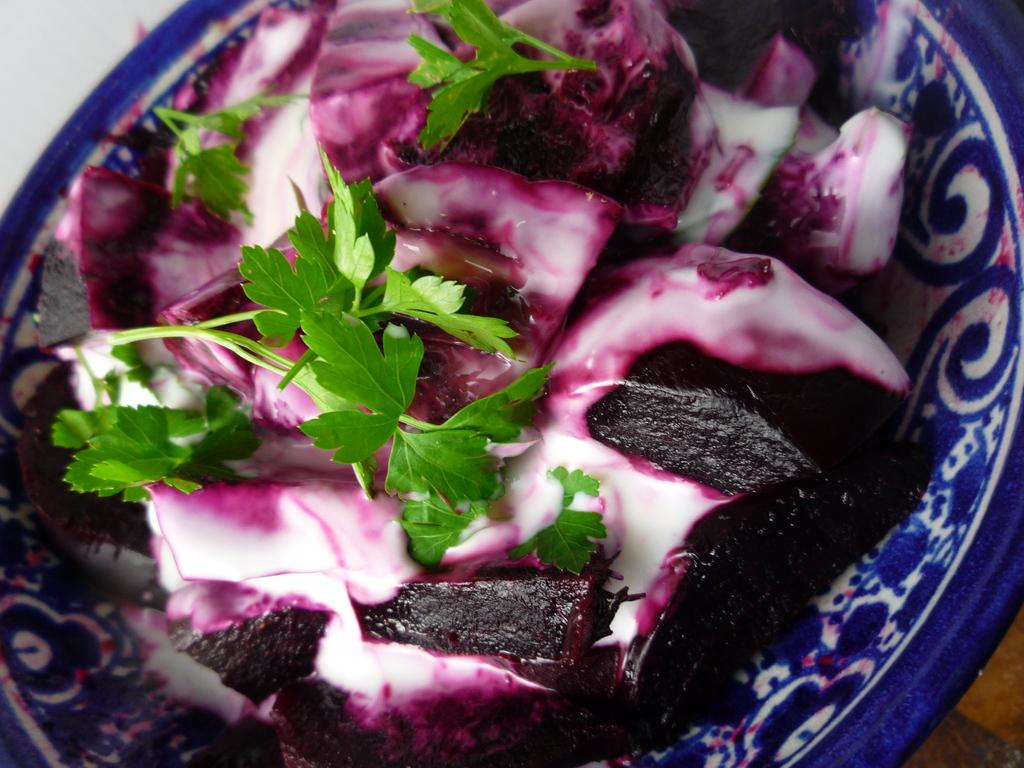What type of food is served in a bowl in the image? There is food served in a bowl in the image, specifically beetroot. Are there any additional ingredients in the bowl? Yes, there is coriander in the bowl. What type of hearing aid is visible in the image? There is no hearing aid present in the image. What type of jar is used to store the food in the image? The image does not show a jar being used to store the food; it is served in a bowl. 